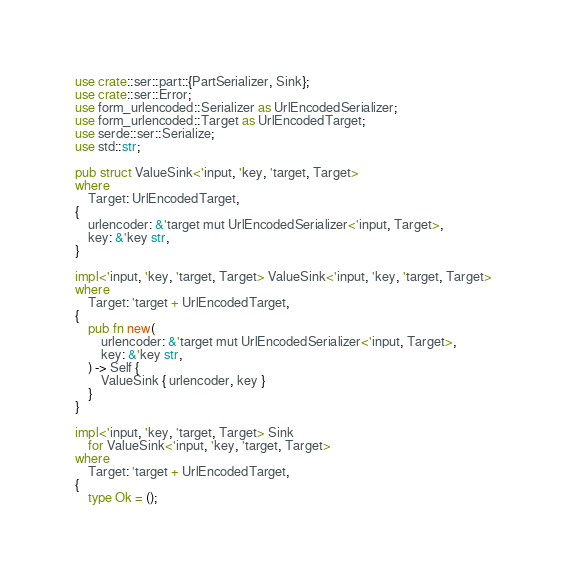<code> <loc_0><loc_0><loc_500><loc_500><_Rust_>use crate::ser::part::{PartSerializer, Sink};
use crate::ser::Error;
use form_urlencoded::Serializer as UrlEncodedSerializer;
use form_urlencoded::Target as UrlEncodedTarget;
use serde::ser::Serialize;
use std::str;

pub struct ValueSink<'input, 'key, 'target, Target>
where
    Target: UrlEncodedTarget,
{
    urlencoder: &'target mut UrlEncodedSerializer<'input, Target>,
    key: &'key str,
}

impl<'input, 'key, 'target, Target> ValueSink<'input, 'key, 'target, Target>
where
    Target: 'target + UrlEncodedTarget,
{
    pub fn new(
        urlencoder: &'target mut UrlEncodedSerializer<'input, Target>,
        key: &'key str,
    ) -> Self {
        ValueSink { urlencoder, key }
    }
}

impl<'input, 'key, 'target, Target> Sink
    for ValueSink<'input, 'key, 'target, Target>
where
    Target: 'target + UrlEncodedTarget,
{
    type Ok = ();
</code> 